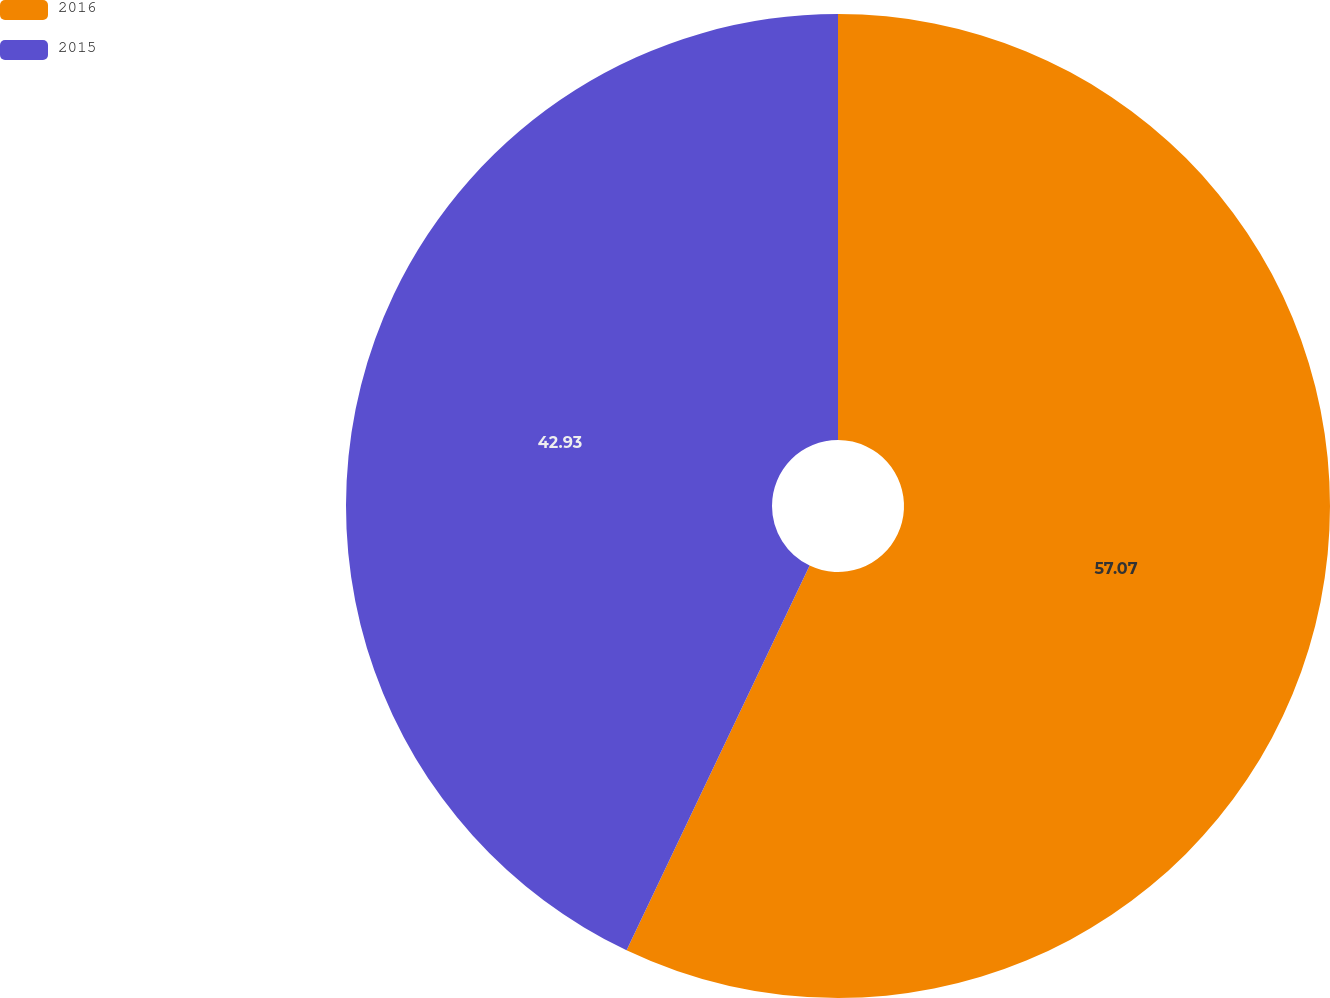Convert chart. <chart><loc_0><loc_0><loc_500><loc_500><pie_chart><fcel>2016<fcel>2015<nl><fcel>57.07%<fcel>42.93%<nl></chart> 